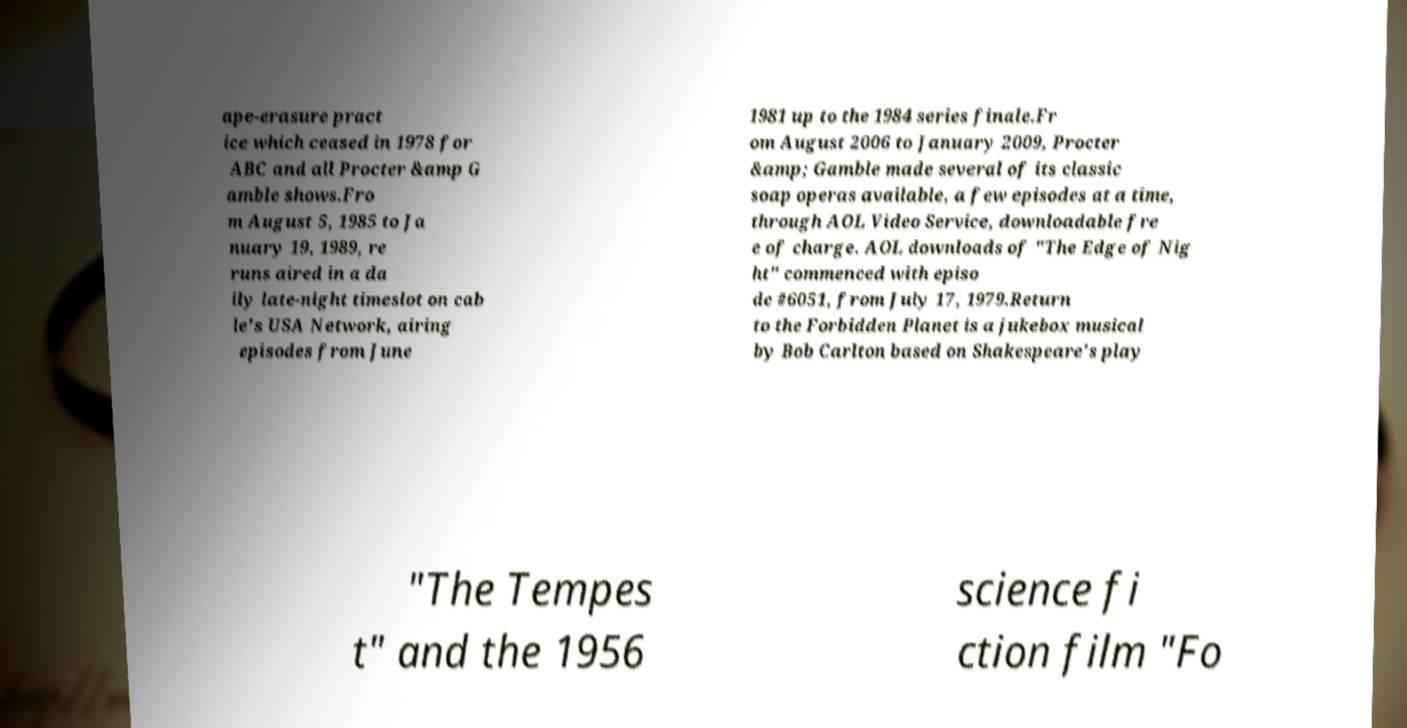There's text embedded in this image that I need extracted. Can you transcribe it verbatim? ape-erasure pract ice which ceased in 1978 for ABC and all Procter &amp G amble shows.Fro m August 5, 1985 to Ja nuary 19, 1989, re runs aired in a da ily late-night timeslot on cab le's USA Network, airing episodes from June 1981 up to the 1984 series finale.Fr om August 2006 to January 2009, Procter &amp; Gamble made several of its classic soap operas available, a few episodes at a time, through AOL Video Service, downloadable fre e of charge. AOL downloads of "The Edge of Nig ht" commenced with episo de #6051, from July 17, 1979.Return to the Forbidden Planet is a jukebox musical by Bob Carlton based on Shakespeare's play "The Tempes t" and the 1956 science fi ction film "Fo 